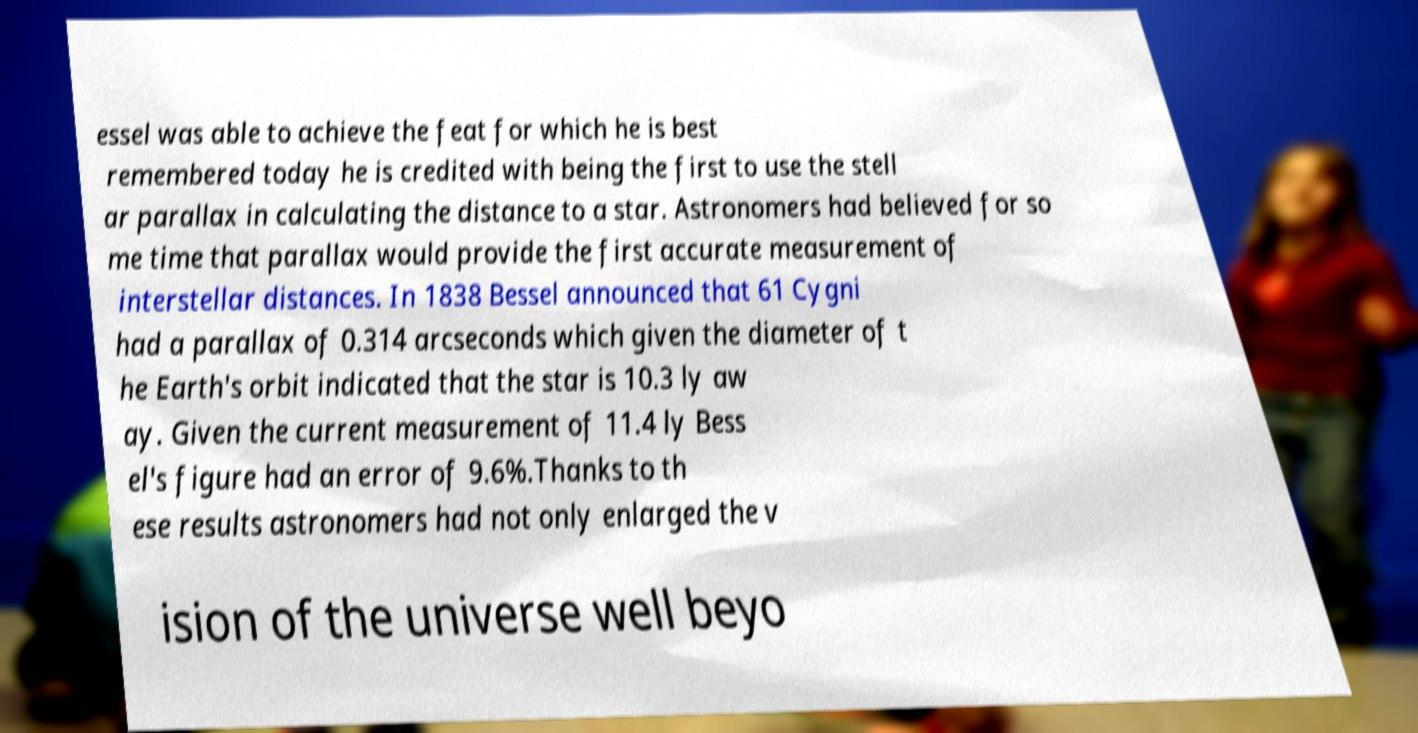Could you assist in decoding the text presented in this image and type it out clearly? essel was able to achieve the feat for which he is best remembered today he is credited with being the first to use the stell ar parallax in calculating the distance to a star. Astronomers had believed for so me time that parallax would provide the first accurate measurement of interstellar distances. In 1838 Bessel announced that 61 Cygni had a parallax of 0.314 arcseconds which given the diameter of t he Earth's orbit indicated that the star is 10.3 ly aw ay. Given the current measurement of 11.4 ly Bess el's figure had an error of 9.6%.Thanks to th ese results astronomers had not only enlarged the v ision of the universe well beyo 